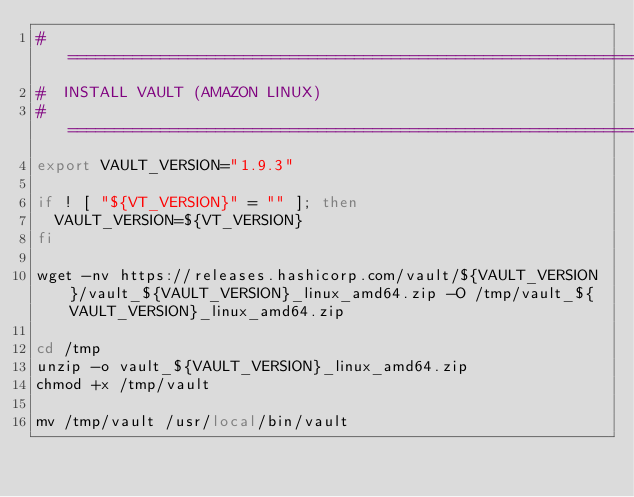<code> <loc_0><loc_0><loc_500><loc_500><_Bash_># ================================================================================================
#  INSTALL VAULT (AMAZON LINUX)
# ================================================================================================
export VAULT_VERSION="1.9.3"

if ! [ "${VT_VERSION}" = "" ]; then
  VAULT_VERSION=${VT_VERSION}
fi

wget -nv https://releases.hashicorp.com/vault/${VAULT_VERSION}/vault_${VAULT_VERSION}_linux_amd64.zip -O /tmp/vault_${VAULT_VERSION}_linux_amd64.zip

cd /tmp
unzip -o vault_${VAULT_VERSION}_linux_amd64.zip
chmod +x /tmp/vault

mv /tmp/vault /usr/local/bin/vault
</code> 